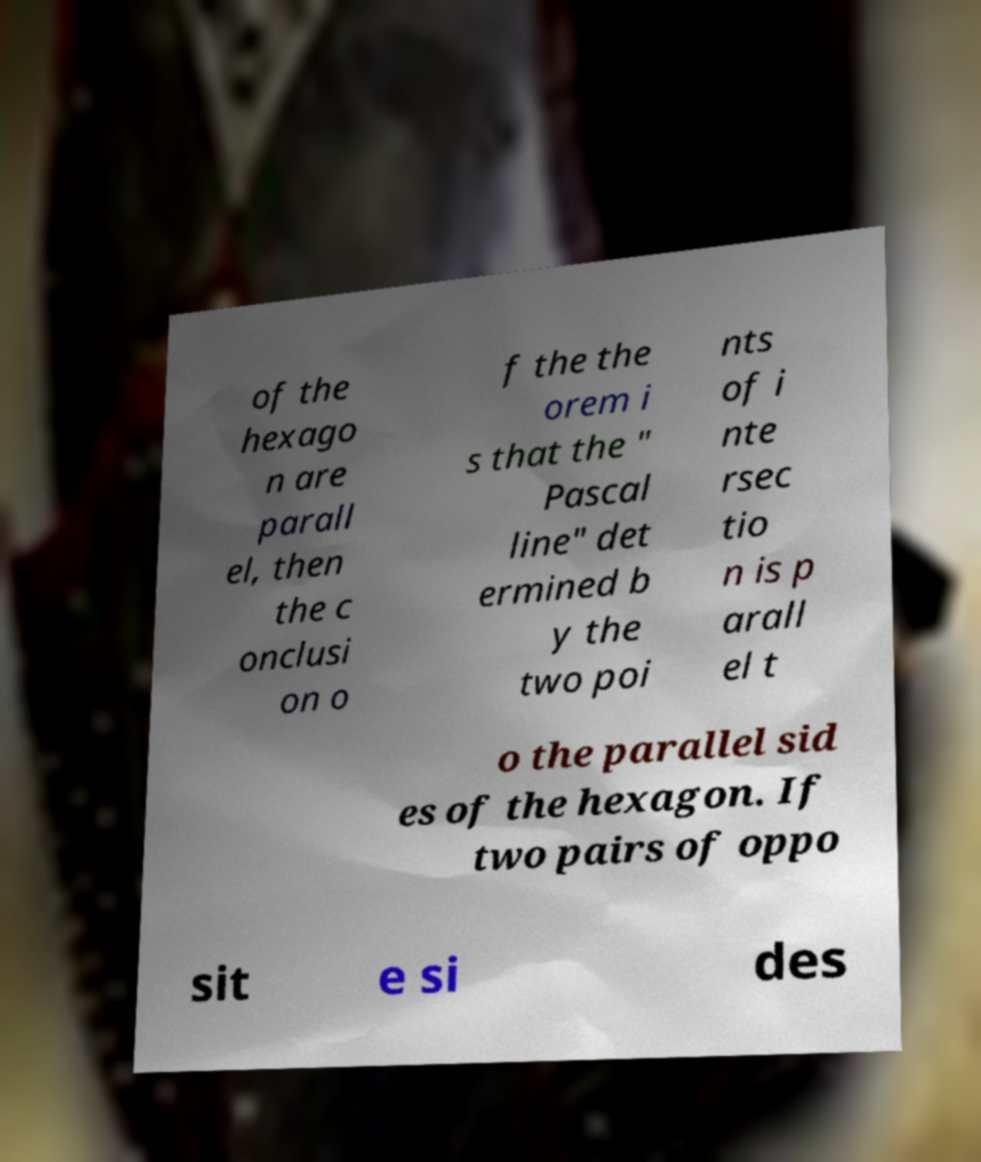Could you assist in decoding the text presented in this image and type it out clearly? of the hexago n are parall el, then the c onclusi on o f the the orem i s that the " Pascal line" det ermined b y the two poi nts of i nte rsec tio n is p arall el t o the parallel sid es of the hexagon. If two pairs of oppo sit e si des 